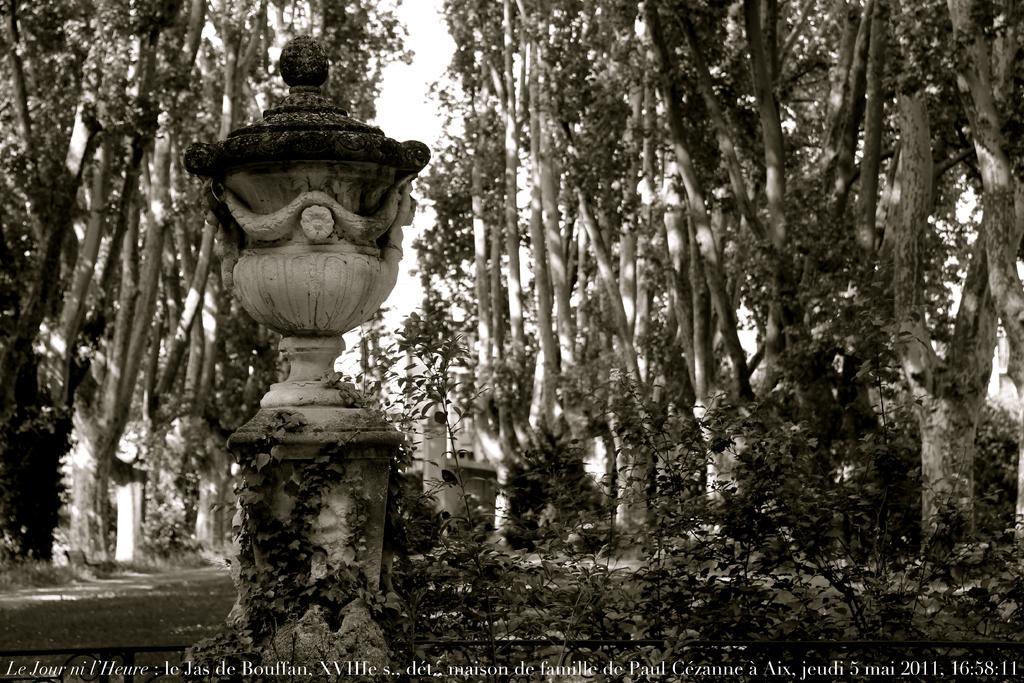How would you summarize this image in a sentence or two? In this image we can see a fountain. In the background there are trees and sky. 